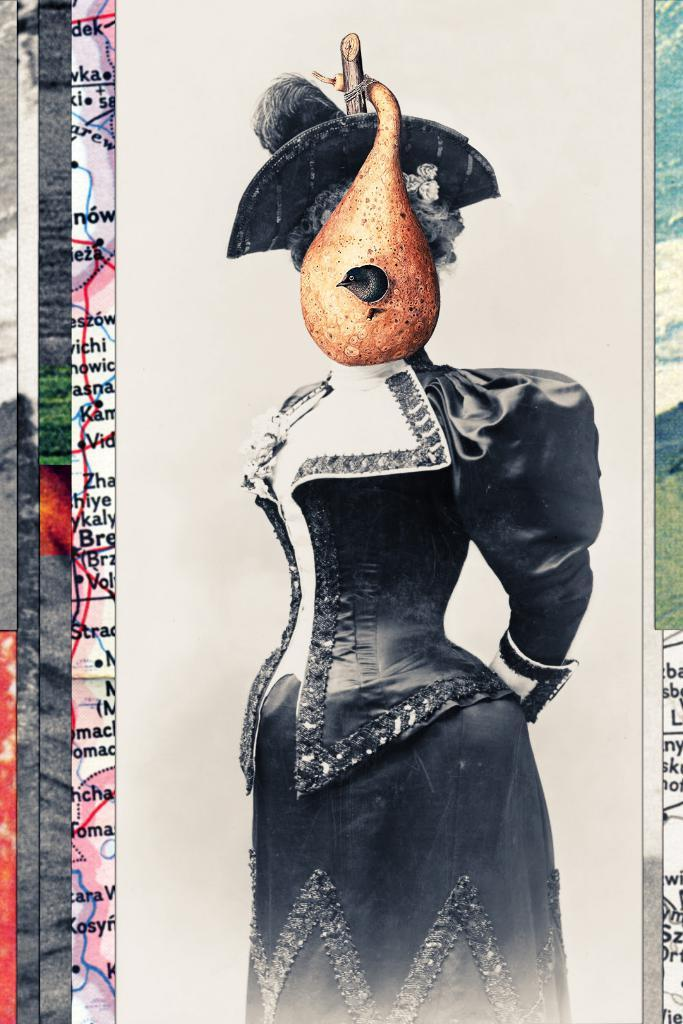What is the main subject of the image? The main subject of the image is a person's wall painting. What type of natural environment can be seen in the image? There is grass visible in the image. What is visible in the background of the image? The sky is visible in the image. When was the image taken? The image was taken during the day. How many tents are set up near the wall painting in the image? There are no tents present in the image; it only features a wall painting, grass, and the sky. What type of border is depicted in the wall painting? There is no border depicted in the wall painting, as the image only shows the painting itself and not its details. 